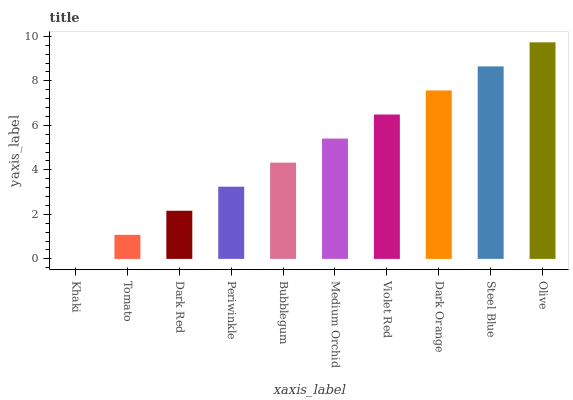Is Tomato the minimum?
Answer yes or no. No. Is Tomato the maximum?
Answer yes or no. No. Is Tomato greater than Khaki?
Answer yes or no. Yes. Is Khaki less than Tomato?
Answer yes or no. Yes. Is Khaki greater than Tomato?
Answer yes or no. No. Is Tomato less than Khaki?
Answer yes or no. No. Is Medium Orchid the high median?
Answer yes or no. Yes. Is Bubblegum the low median?
Answer yes or no. Yes. Is Dark Red the high median?
Answer yes or no. No. Is Khaki the low median?
Answer yes or no. No. 